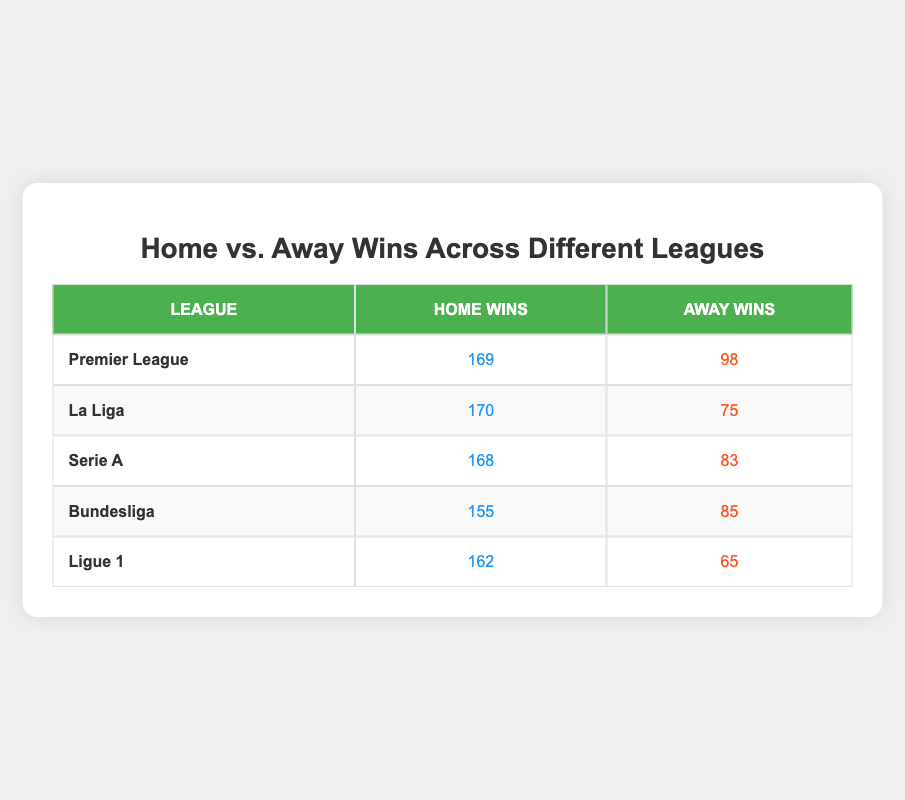What league has the highest number of home wins? By examining the "Home Wins" column in the table, the Premier League has 169 home wins, which is the highest number compared to the other leagues listed.
Answer: Premier League What is the total number of away wins in Serie A and Bundesliga combined? To find the total, we need to add the away wins from both leagues: Serie A has 83 away wins and Bundesliga has 85 away wins. Thus, 83 + 85 = 168.
Answer: 168 Is it true that Ligue 1 has more away wins than the Bundesliga? Checking the "Away Wins" column, Ligue 1 has 65 away wins while Bundesliga has 85 away wins. Since 65 is less than 85, the statement is false.
Answer: No How many more home wins does La Liga have compared to Ligue 1? To find the difference, we subtract the home wins in Ligue 1 from that in La Liga: 170 (La Liga) - 162 (Ligue 1) = 8.
Answer: 8 What is the average number of home wins across all leagues? To calculate the average, we sum the home wins for all leagues (169 + 170 + 168 + 155 + 162 = 824) and then divide by the number of leagues (5). Therefore, the average is 824 / 5 = 164.8.
Answer: 164.8 